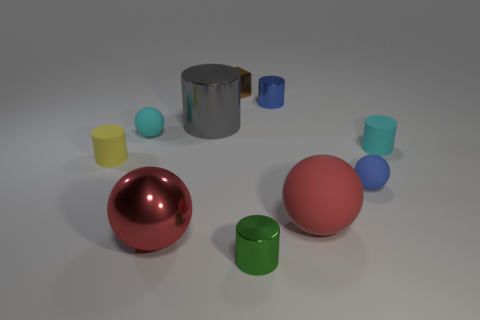What number of shiny objects are both to the right of the large red shiny thing and in front of the blue matte thing? Upon careful examination of the image, it appears there is one shiny green cylinder that is positioned both to the right of the large red sphere and in front of the blue cylinder, which possesses a matte finish. 